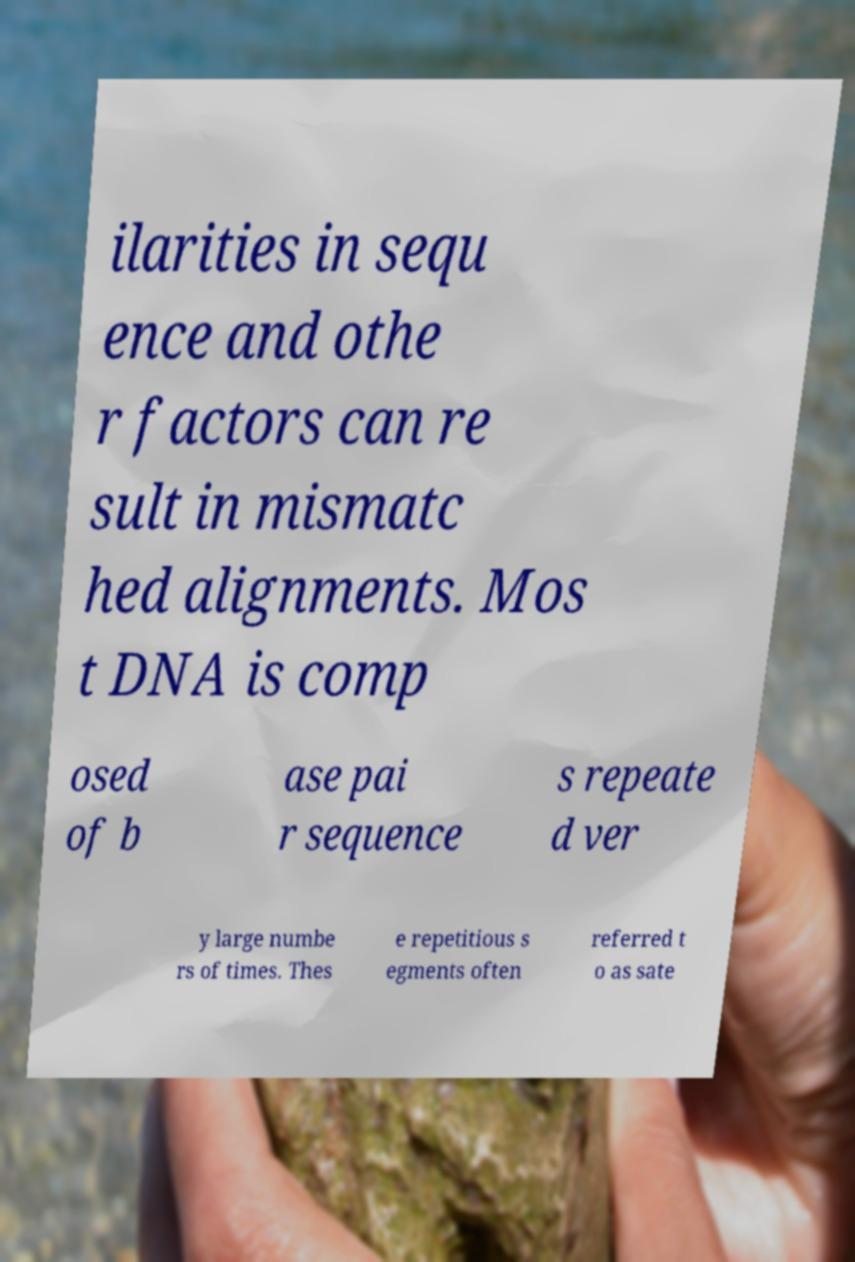Could you extract and type out the text from this image? ilarities in sequ ence and othe r factors can re sult in mismatc hed alignments. Mos t DNA is comp osed of b ase pai r sequence s repeate d ver y large numbe rs of times. Thes e repetitious s egments often referred t o as sate 